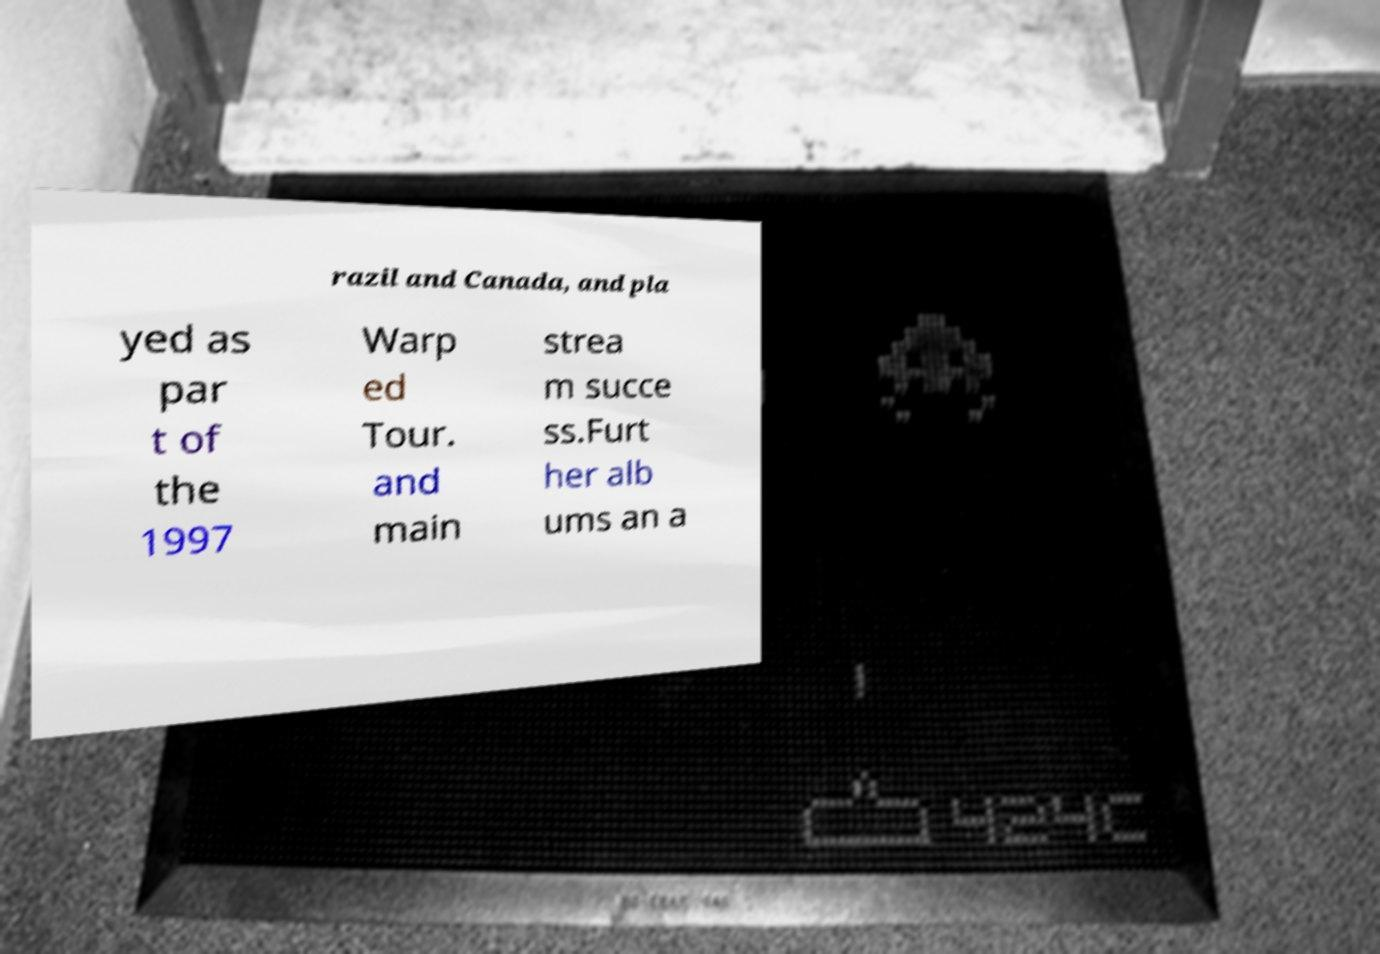I need the written content from this picture converted into text. Can you do that? razil and Canada, and pla yed as par t of the 1997 Warp ed Tour. and main strea m succe ss.Furt her alb ums an a 